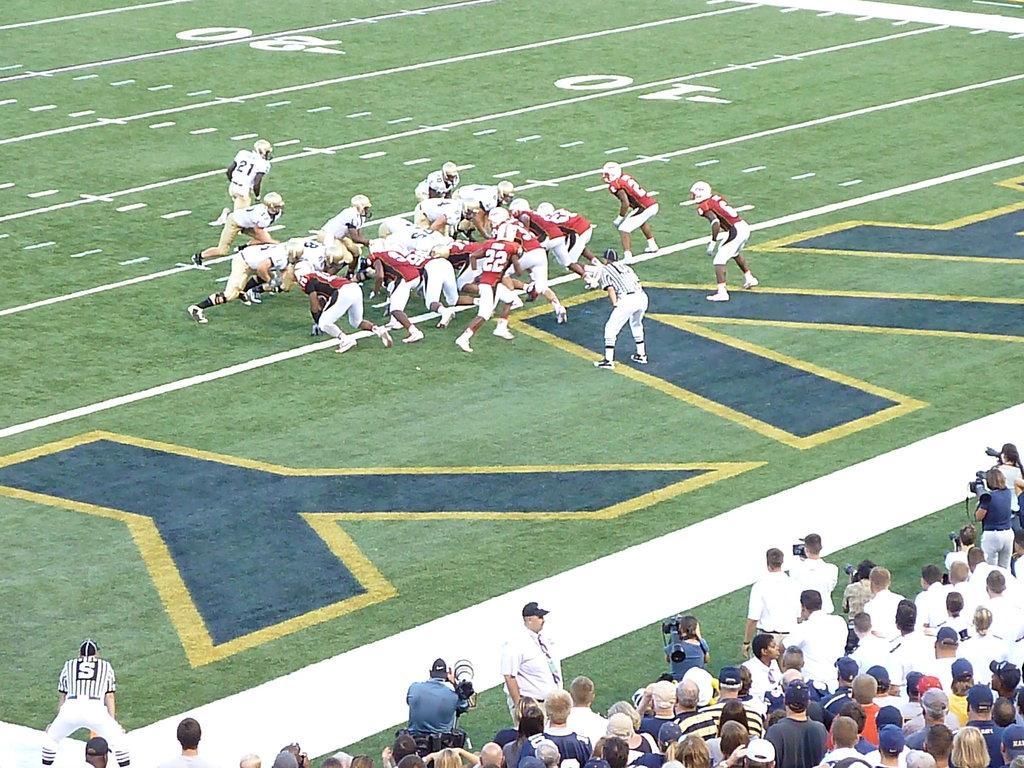Could you give a brief overview of what you see in this image? In this image I can see few people are playing the game in the ground. On the bottom of the image I can see few people are looking at those people. Here I can see few men are holding the cameras in their hands. 